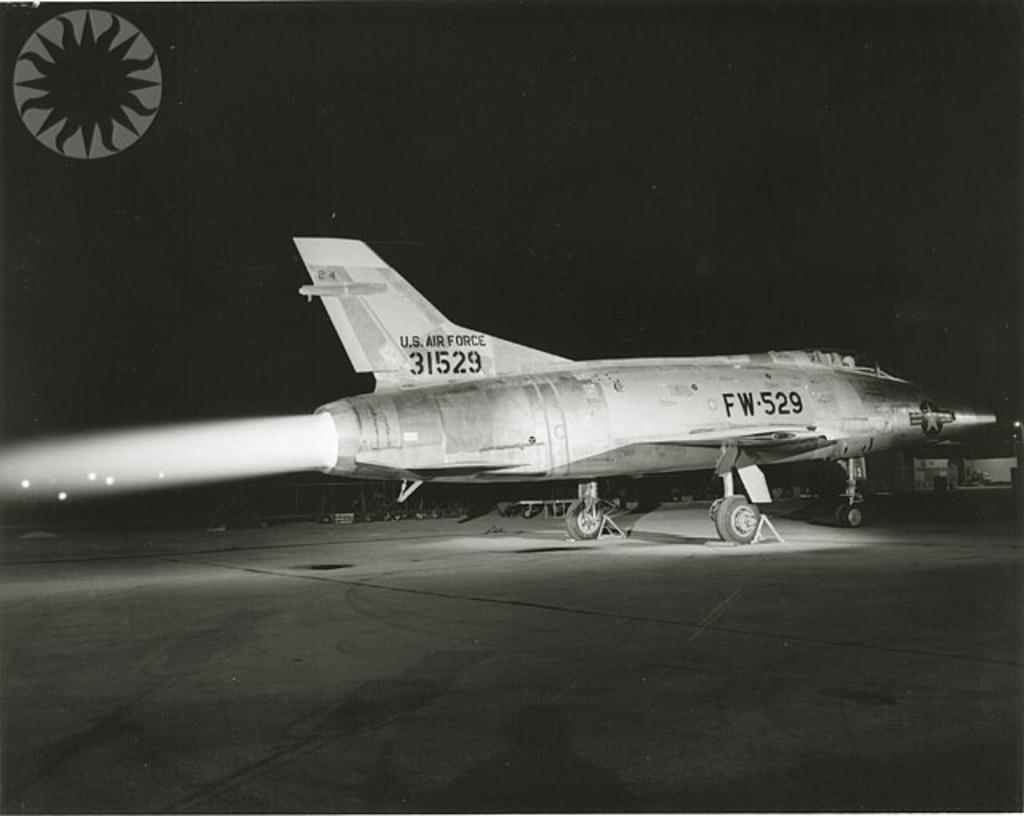<image>
Provide a brief description of the given image. A U.S. Air Force fighter jet is parked on the runway. 